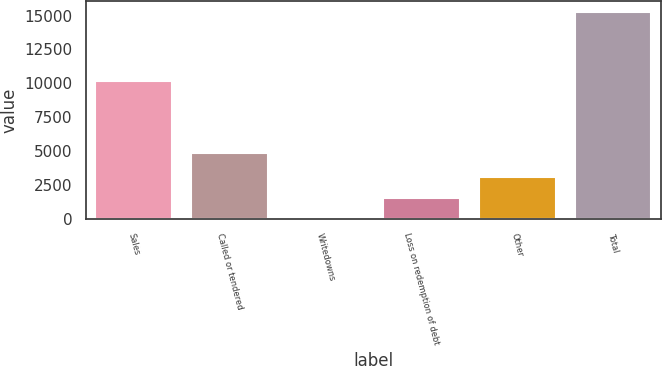<chart> <loc_0><loc_0><loc_500><loc_500><bar_chart><fcel>Sales<fcel>Called or tendered<fcel>Writedowns<fcel>Loss on redemption of debt<fcel>Other<fcel>Total<nl><fcel>10209<fcel>4851<fcel>2.53<fcel>1532.88<fcel>3063.23<fcel>15306<nl></chart> 